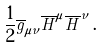Convert formula to latex. <formula><loc_0><loc_0><loc_500><loc_500>\frac { 1 } { 2 } \overline { g } _ { \mu \nu } \overline { H } ^ { \mu } \overline { H } ^ { \nu } \, .</formula> 